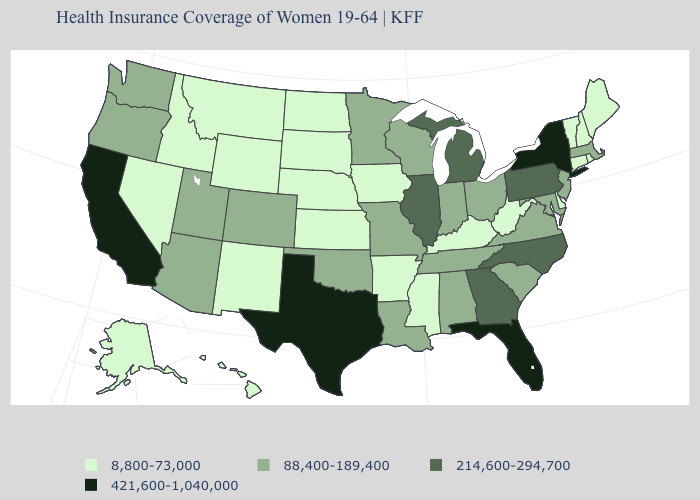Name the states that have a value in the range 88,400-189,400?
Keep it brief. Alabama, Arizona, Colorado, Indiana, Louisiana, Maryland, Massachusetts, Minnesota, Missouri, New Jersey, Ohio, Oklahoma, Oregon, South Carolina, Tennessee, Utah, Virginia, Washington, Wisconsin. What is the value of Texas?
Quick response, please. 421,600-1,040,000. What is the value of Illinois?
Give a very brief answer. 214,600-294,700. Among the states that border New Hampshire , which have the highest value?
Write a very short answer. Massachusetts. What is the lowest value in the South?
Be succinct. 8,800-73,000. Name the states that have a value in the range 214,600-294,700?
Answer briefly. Georgia, Illinois, Michigan, North Carolina, Pennsylvania. Which states have the lowest value in the MidWest?
Concise answer only. Iowa, Kansas, Nebraska, North Dakota, South Dakota. Name the states that have a value in the range 421,600-1,040,000?
Keep it brief. California, Florida, New York, Texas. Does the first symbol in the legend represent the smallest category?
Write a very short answer. Yes. What is the highest value in the USA?
Quick response, please. 421,600-1,040,000. What is the value of North Carolina?
Keep it brief. 214,600-294,700. Does the map have missing data?
Write a very short answer. No. Which states have the lowest value in the USA?
Concise answer only. Alaska, Arkansas, Connecticut, Delaware, Hawaii, Idaho, Iowa, Kansas, Kentucky, Maine, Mississippi, Montana, Nebraska, Nevada, New Hampshire, New Mexico, North Dakota, Rhode Island, South Dakota, Vermont, West Virginia, Wyoming. Which states hav the highest value in the West?
Keep it brief. California. Name the states that have a value in the range 214,600-294,700?
Write a very short answer. Georgia, Illinois, Michigan, North Carolina, Pennsylvania. 